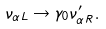<formula> <loc_0><loc_0><loc_500><loc_500>\nu _ { \alpha L } \to \gamma _ { 0 } \nu ^ { \prime } _ { \alpha R } .</formula> 